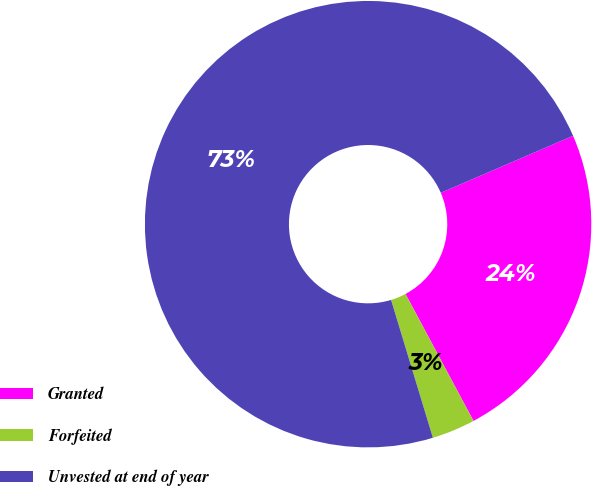<chart> <loc_0><loc_0><loc_500><loc_500><pie_chart><fcel>Granted<fcel>Forfeited<fcel>Unvested at end of year<nl><fcel>23.65%<fcel>3.14%<fcel>73.2%<nl></chart> 